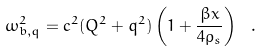<formula> <loc_0><loc_0><loc_500><loc_500>\omega _ { b , q } ^ { 2 } = c ^ { 2 } ( Q ^ { 2 } + q ^ { 2 } ) \left ( 1 + \frac { \beta x } { 4 \rho _ { s } } \right ) \ .</formula> 